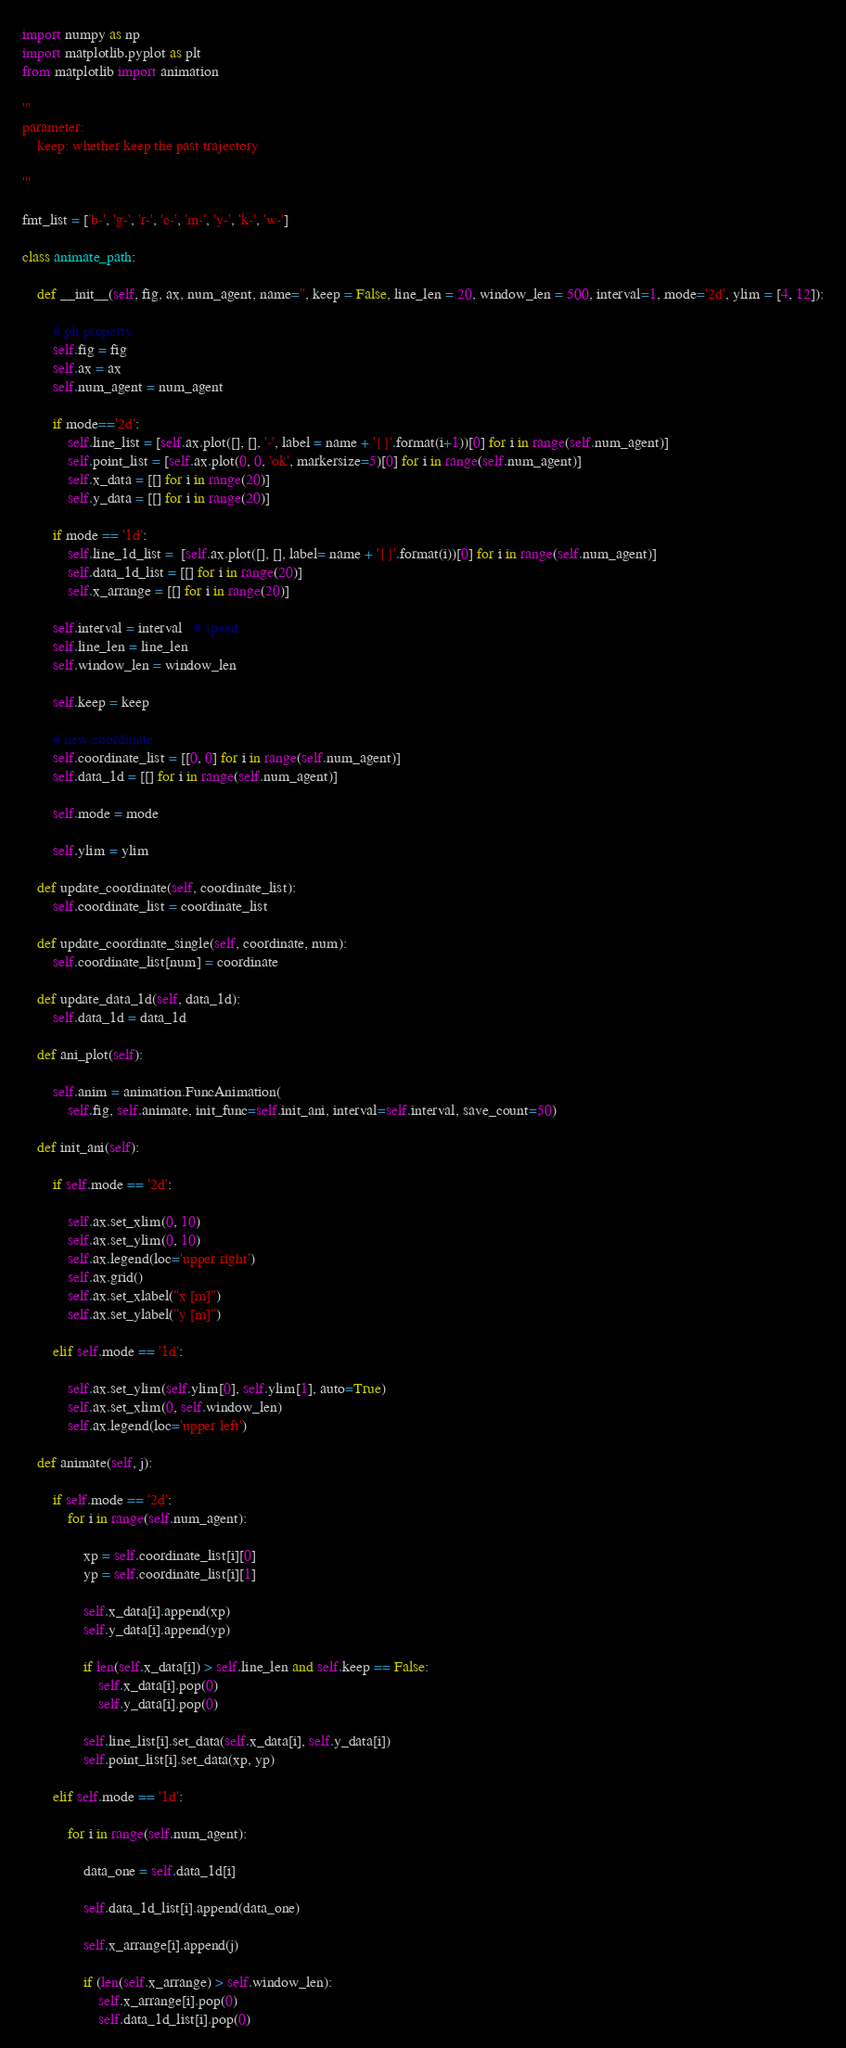Convert code to text. <code><loc_0><loc_0><loc_500><loc_500><_Python_>import numpy as np
import matplotlib.pyplot as plt
from matplotlib import animation

'''
parameter: 
    keep: whether keep the past trajectory 

'''

fmt_list = ['b-', 'g-', 'r-', 'c-', 'm-', 'y-', 'k-', 'w-']

class animate_path:

    def __init__(self, fig, ax, num_agent, name='', keep = False, line_len = 20, window_len = 500, interval=1, mode='2d', ylim = [4, 12]):

        # plt property
        self.fig = fig
        self.ax = ax
        self.num_agent = num_agent

        if mode=='2d':
            self.line_list = [self.ax.plot([], [], '-', label = name + '{}'.format(i+1))[0] for i in range(self.num_agent)]
            self.point_list = [self.ax.plot(0, 0, 'ok', markersize=5)[0] for i in range(self.num_agent)]
            self.x_data = [[] for i in range(20)]
            self.y_data = [[] for i in range(20)]

        if mode == '1d':
            self.line_1d_list =  [self.ax.plot([], [], label= name + '{}'.format(i))[0] for i in range(self.num_agent)]
            self.data_1d_list = [[] for i in range(20)]
            self.x_arrange = [[] for i in range(20)]

        self.interval = interval   # speed
        self.line_len = line_len
        self.window_len = window_len

        self.keep = keep
         
        # new coordinate
        self.coordinate_list = [[0, 0] for i in range(self.num_agent)]
        self.data_1d = [[] for i in range(self.num_agent)]

        self.mode = mode

        self.ylim = ylim

    def update_coordinate(self, coordinate_list):
        self.coordinate_list = coordinate_list

    def update_coordinate_single(self, coordinate, num):
        self.coordinate_list[num] = coordinate

    def update_data_1d(self, data_1d):
        self.data_1d = data_1d

    def ani_plot(self):

        self.anim = animation.FuncAnimation(
            self.fig, self.animate, init_func=self.init_ani, interval=self.interval, save_count=50)

    def init_ani(self):

        if self.mode == '2d':
            
            self.ax.set_xlim(0, 10)
            self.ax.set_ylim(0, 10)
            self.ax.legend(loc='upper right')
            self.ax.grid()
            self.ax.set_xlabel("x [m]")
            self.ax.set_ylabel("y [m]")

        elif self.mode == '1d':     

            self.ax.set_ylim(self.ylim[0], self.ylim[1], auto=True)
            self.ax.set_xlim(0, self.window_len)
            self.ax.legend(loc='upper left')

    def animate(self, j):

        if self.mode == '2d':
            for i in range(self.num_agent):
                
                xp = self.coordinate_list[i][0]
                yp = self.coordinate_list[i][1]

                self.x_data[i].append(xp)
                self.y_data[i].append(yp)

                if len(self.x_data[i]) > self.line_len and self.keep == False:
                    self.x_data[i].pop(0)
                    self.y_data[i].pop(0)
                         
                self.line_list[i].set_data(self.x_data[i], self.y_data[i])
                self.point_list[i].set_data(xp, yp)

        elif self.mode == '1d':
            
            for i in range(self.num_agent):
                
                data_one = self.data_1d[i]

                self.data_1d_list[i].append(data_one)

                self.x_arrange[i].append(j)

                if (len(self.x_arrange) > self.window_len):
                    self.x_arrange[i].pop(0)
                    self.data_1d_list[i].pop(0)
</code> 